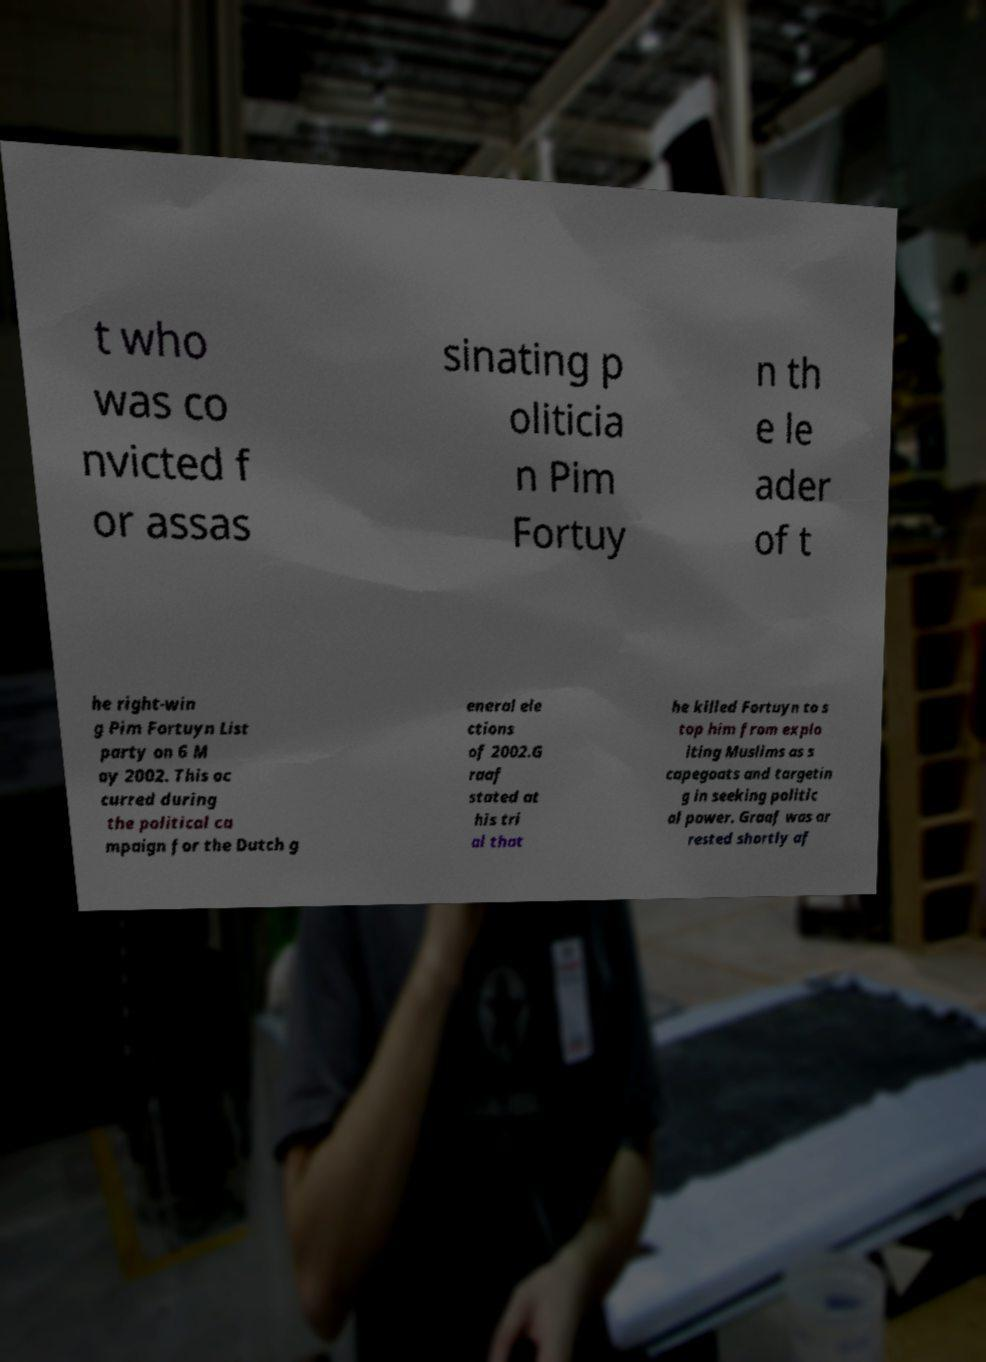I need the written content from this picture converted into text. Can you do that? t who was co nvicted f or assas sinating p oliticia n Pim Fortuy n th e le ader of t he right-win g Pim Fortuyn List party on 6 M ay 2002. This oc curred during the political ca mpaign for the Dutch g eneral ele ctions of 2002.G raaf stated at his tri al that he killed Fortuyn to s top him from explo iting Muslims as s capegoats and targetin g in seeking politic al power. Graaf was ar rested shortly af 